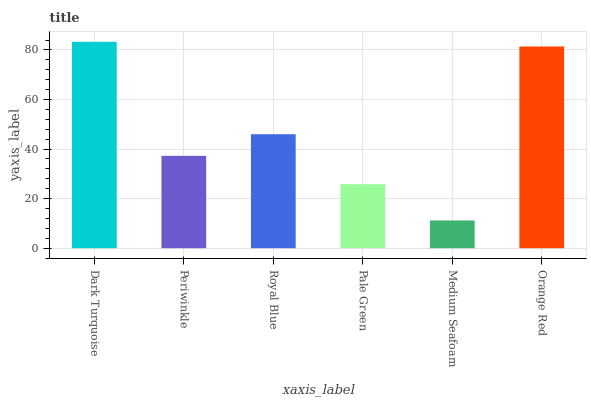Is Medium Seafoam the minimum?
Answer yes or no. Yes. Is Dark Turquoise the maximum?
Answer yes or no. Yes. Is Periwinkle the minimum?
Answer yes or no. No. Is Periwinkle the maximum?
Answer yes or no. No. Is Dark Turquoise greater than Periwinkle?
Answer yes or no. Yes. Is Periwinkle less than Dark Turquoise?
Answer yes or no. Yes. Is Periwinkle greater than Dark Turquoise?
Answer yes or no. No. Is Dark Turquoise less than Periwinkle?
Answer yes or no. No. Is Royal Blue the high median?
Answer yes or no. Yes. Is Periwinkle the low median?
Answer yes or no. Yes. Is Periwinkle the high median?
Answer yes or no. No. Is Orange Red the low median?
Answer yes or no. No. 